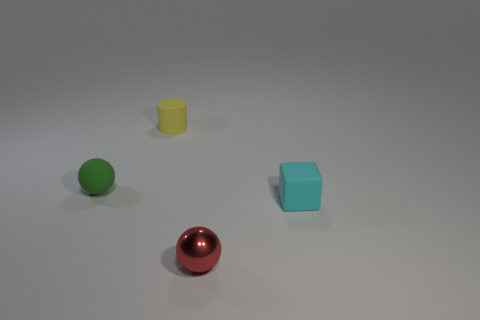Add 3 big gray cubes. How many objects exist? 7 Subtract all green balls. How many balls are left? 1 Subtract 1 cyan blocks. How many objects are left? 3 Subtract all cylinders. How many objects are left? 3 Subtract 1 cubes. How many cubes are left? 0 Subtract all red blocks. Subtract all brown spheres. How many blocks are left? 1 Subtract all green blocks. How many cyan balls are left? 0 Subtract all red things. Subtract all tiny rubber objects. How many objects are left? 0 Add 3 rubber balls. How many rubber balls are left? 4 Add 1 tiny brown things. How many tiny brown things exist? 1 